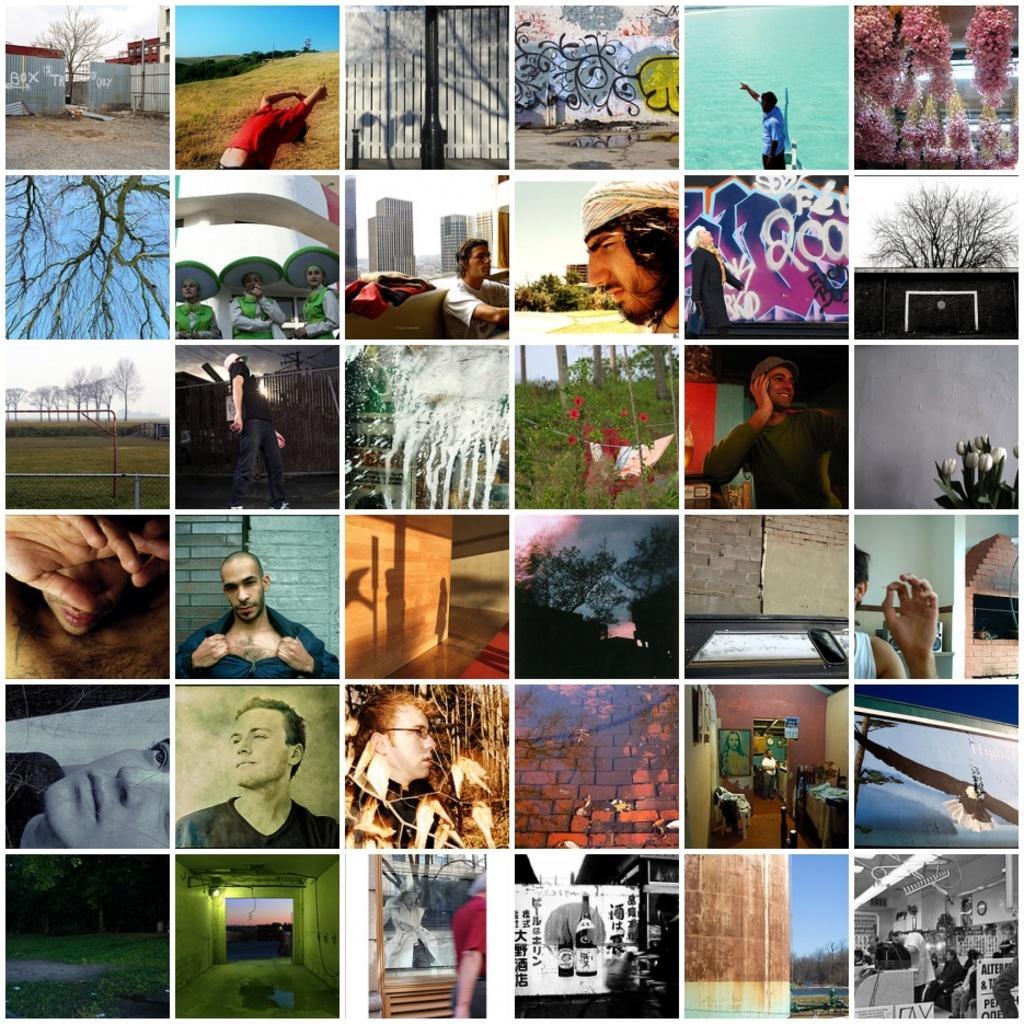Describe this image in one or two sentences. This picture consists of a collage in the image. 